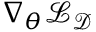Convert formula to latex. <formula><loc_0><loc_0><loc_500><loc_500>\nabla _ { \theta } \mathcal { L } _ { \mathcal { D } }</formula> 